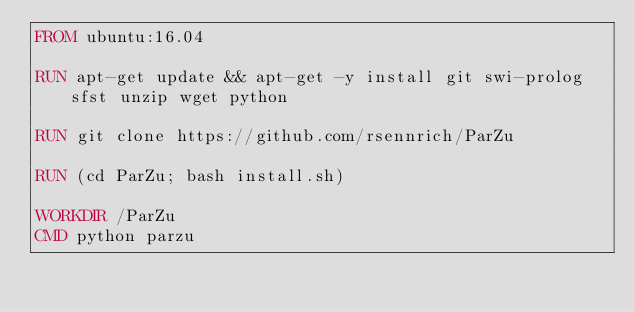<code> <loc_0><loc_0><loc_500><loc_500><_Dockerfile_>FROM ubuntu:16.04

RUN apt-get update && apt-get -y install git swi-prolog sfst unzip wget python

RUN git clone https://github.com/rsennrich/ParZu

RUN (cd ParZu; bash install.sh)

WORKDIR /ParZu
CMD python parzu
</code> 